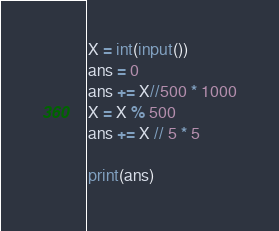<code> <loc_0><loc_0><loc_500><loc_500><_Python_>X = int(input())
ans = 0
ans += X//500 * 1000
X = X % 500
ans += X // 5 * 5

print(ans)</code> 